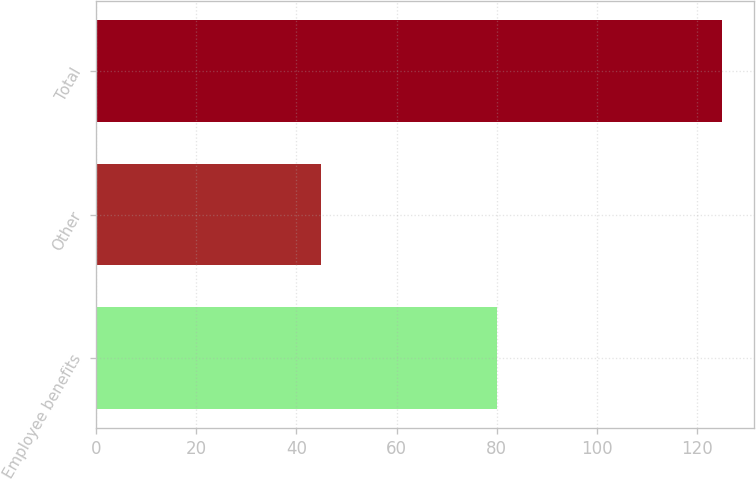Convert chart to OTSL. <chart><loc_0><loc_0><loc_500><loc_500><bar_chart><fcel>Employee benefits<fcel>Other<fcel>Total<nl><fcel>80<fcel>45<fcel>125<nl></chart> 